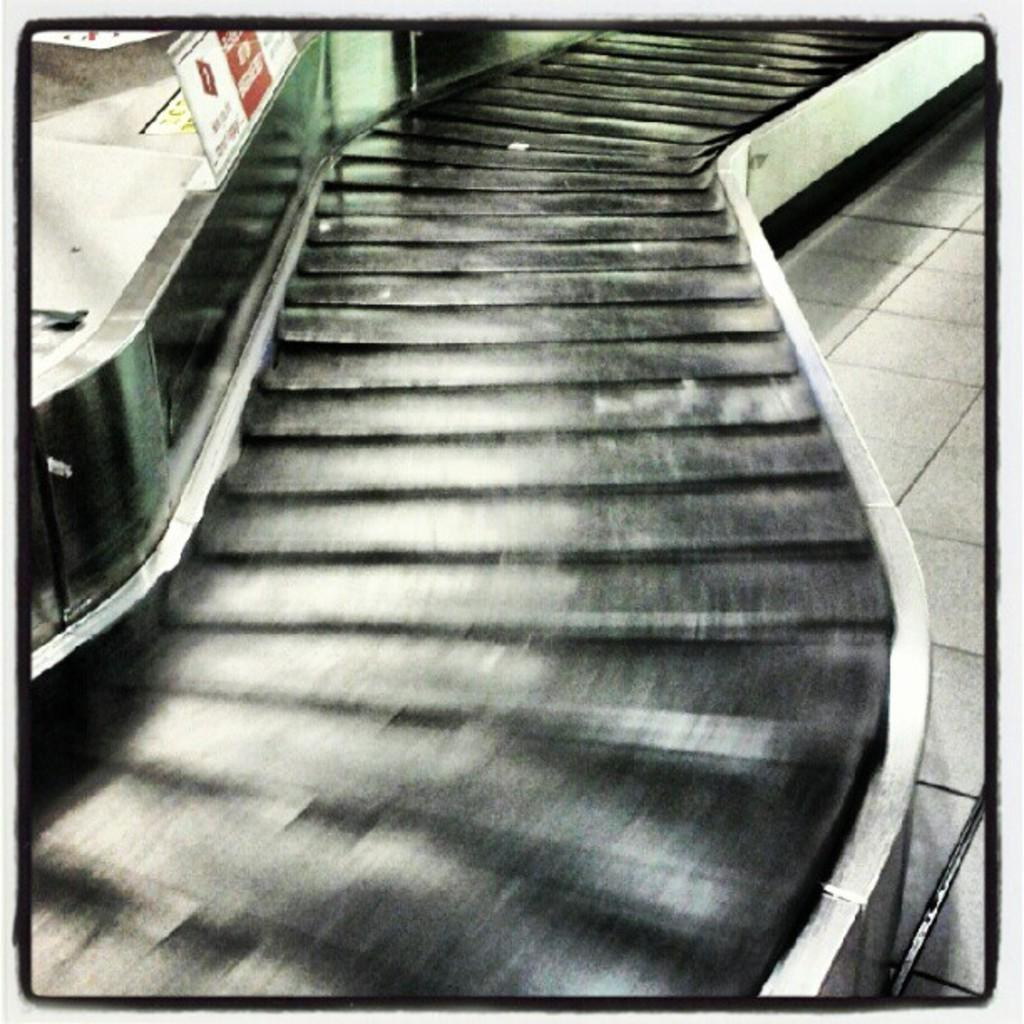What can be seen on the floor in the image? There are stairs on the floor in the image. What is located near the stairs? There is a board at the side of the stairs. What is written on the board? Text is written on the board. Can you see a suit hanging on the stairs in the image? There is no suit visible on the stairs in the image. Is there a kitty playing with the board in the image? There is no kitty present in the image. 